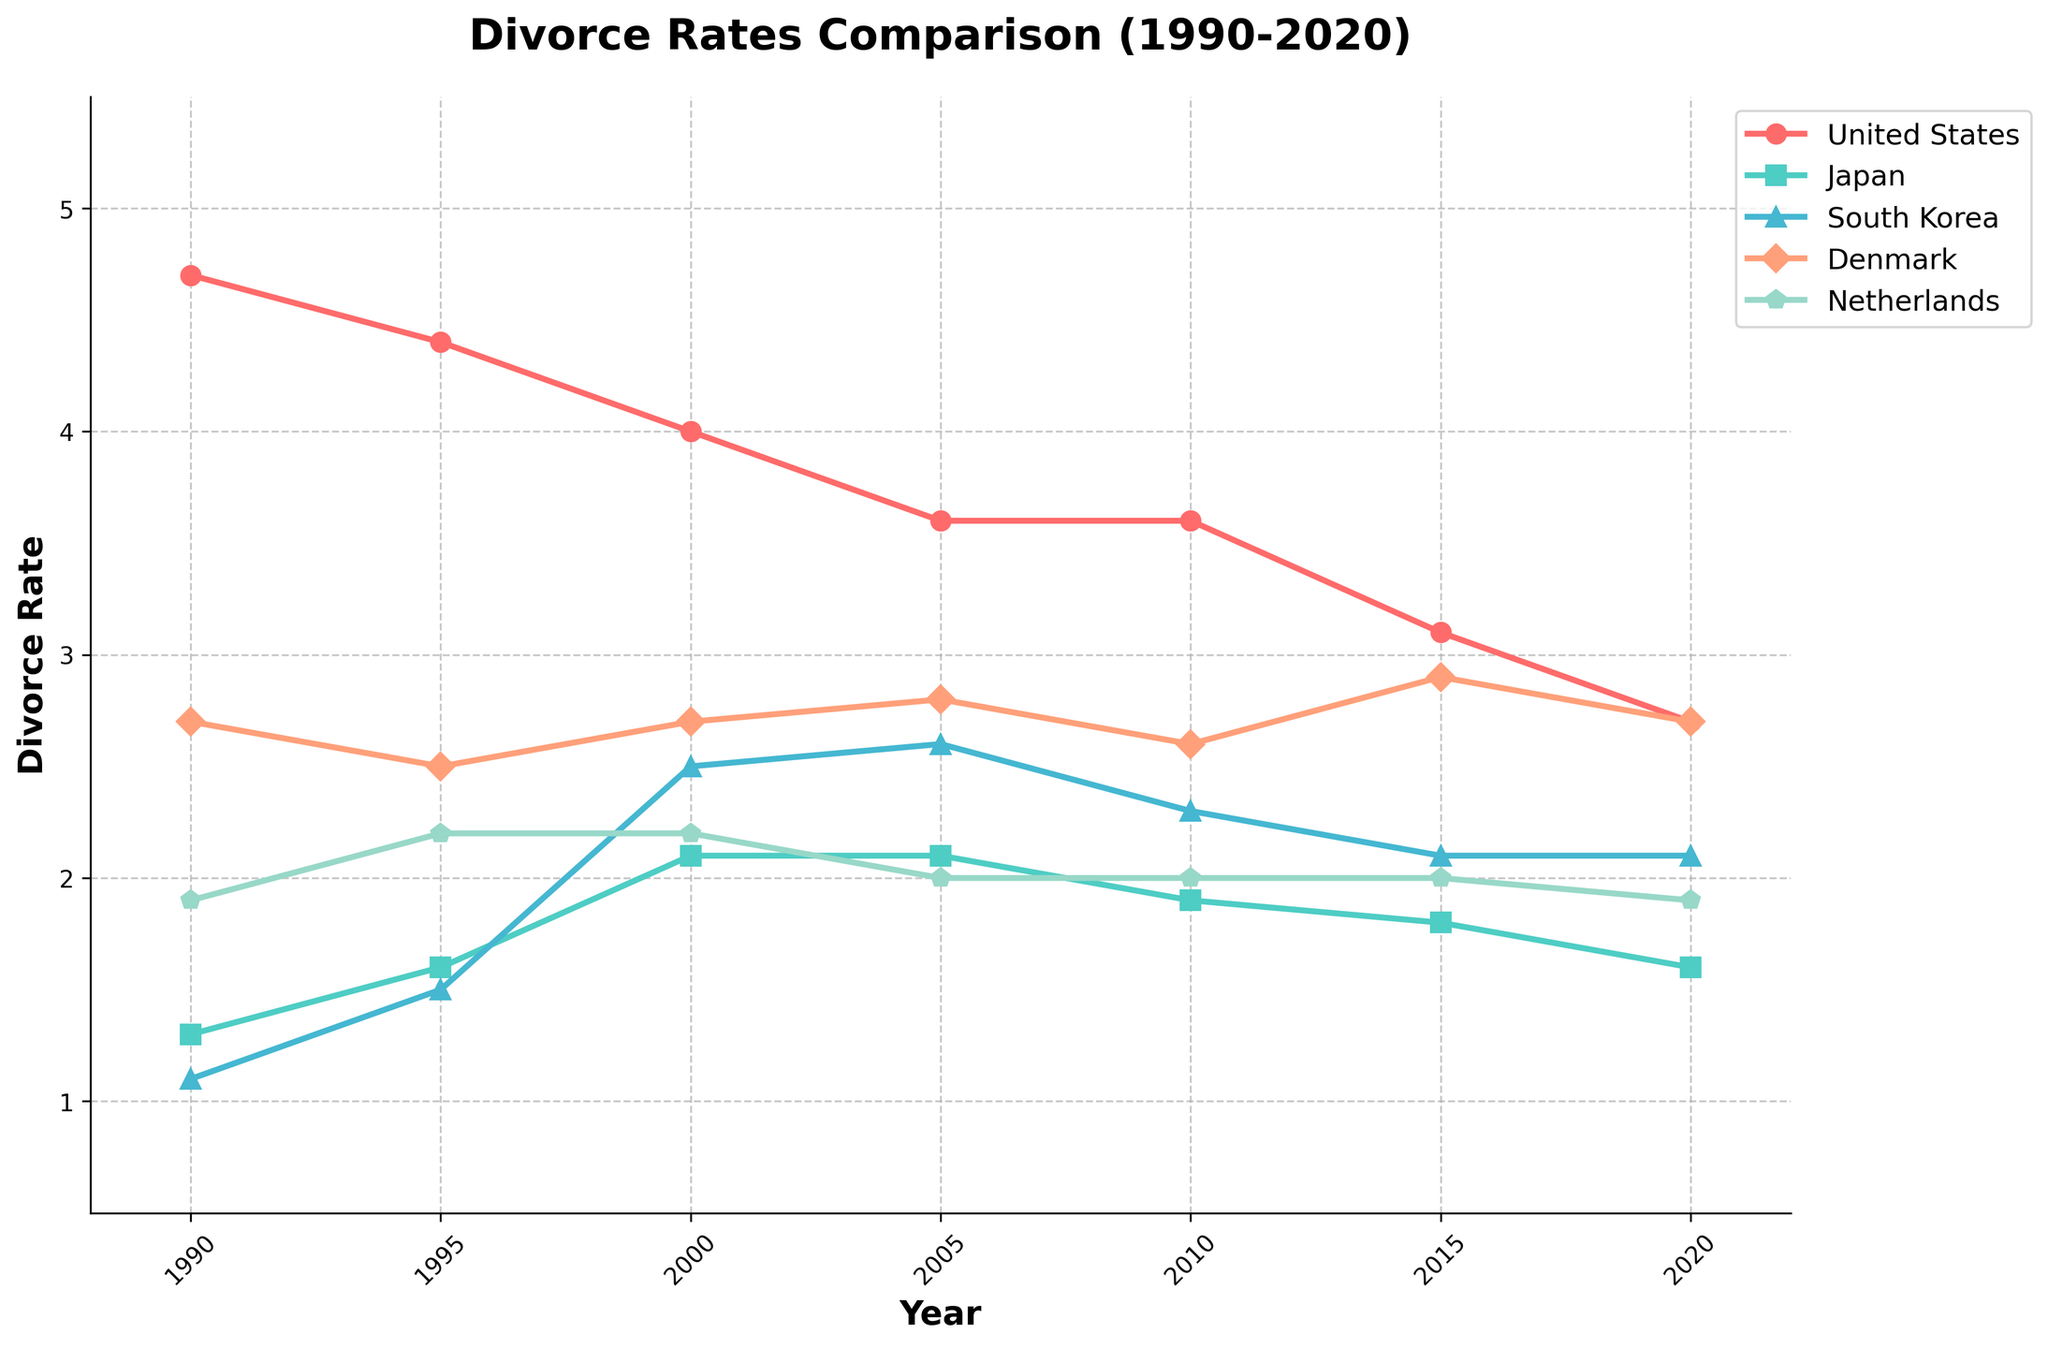What is the overall trend of the divorce rate in the United States from 1990 to 2020? The divorce rate in the United States shows a downward trend from 4.7 in 1990 to 2.7 in 2020. The rate has consistently decreased each decade.
Answer: Downward trend Which country had the lowest divorce rate in 2020? To determine the lowest divorce rate in 2020, observe the endpoints of the lines representing each country. Japan has the lowest value at 1.6.
Answer: Japan Between 2000 and 2010, did South Korea’s divorce rate increase or decrease? By comparing the data points for South Korea in 2000 and 2010 on the plot, we see that the rate decreased from 2.5 to 2.3.
Answer: Decrease How did the divorce rate in Denmark change from 1995 to 2020? Observe the data points for Denmark between 1995 and 2020 on the plot. The divorce rate shows a fluctuating trend, starting at 2.5 in 1995 and ending at 2.7 in 2020, with variations in between.
Answer: Fluctuating, but overall increase Which country had the most stable divorce rate over the 30-year period? To determine the most stability, look for the least variation among countries. Japan’s divorce rate remains within a narrow range of 1.3 to 2.1.
Answer: Japan In 2015, which country had the highest divorce rate? By evaluating the data points for each country in 2015, Denmark has the highest rate at 2.9.
Answer: Denmark Compare the divorce rates of the United States and the Netherlands in 2005. Which one had a higher rate? Observe the two data points for the United States and the Netherlands in 2005. The United States had a higher rate at 3.6, compared to the Netherlands' 2.0.
Answer: United States What is the difference in the divorce rate between Denmark and South Korea in 2000? Evaluate the data points for Denmark and South Korea in 2000. Denmark’s rate is 2.7 and South Korea’s is 2.5. The difference is 0.2.
Answer: 0.2 In which year did South Korea experience the most significant divorce rate increase, and what was the change? Comparing the year-over-year changes for South Korea, the biggest increase occurred between 1995 and 2000, rising from 1.5 to 2.5, a change of 1.0.
Answer: 2000, increase of 1.0 Across all the years, which country had the highest singular divorce rate, and in what year? Examine the maximum values for each country. The United States had the highest rate in 1990, which was 4.7.
Answer: United States, 1990 